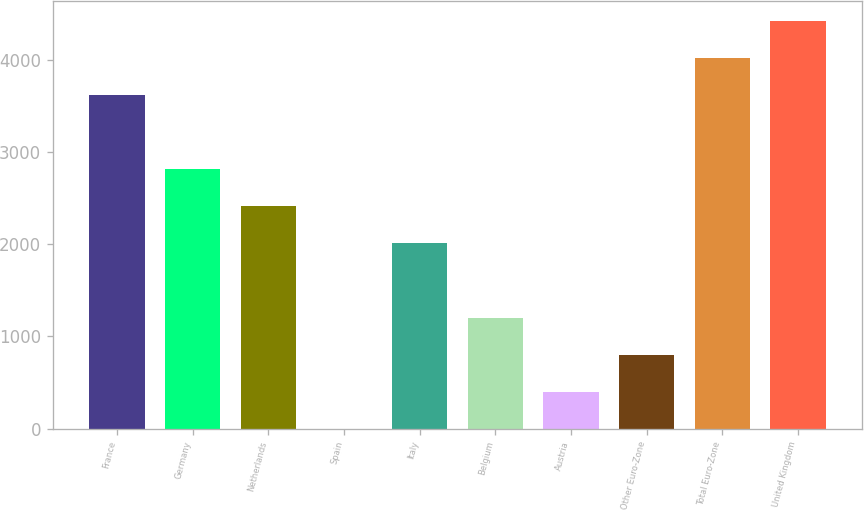<chart> <loc_0><loc_0><loc_500><loc_500><bar_chart><fcel>France<fcel>Germany<fcel>Netherlands<fcel>Spain<fcel>Italy<fcel>Belgium<fcel>Austria<fcel>Other Euro-Zone<fcel>Total Euro-Zone<fcel>United Kingdom<nl><fcel>3613.6<fcel>2810.8<fcel>2409.4<fcel>1<fcel>2008<fcel>1205.2<fcel>402.4<fcel>803.8<fcel>4015<fcel>4416.4<nl></chart> 